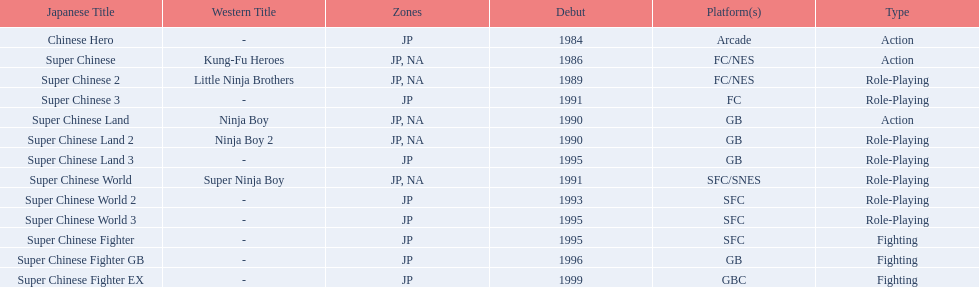Could you parse the entire table as a dict? {'header': ['Japanese Title', 'Western Title', 'Zones', 'Debut', 'Platform(s)', 'Type'], 'rows': [['Chinese Hero', '-', 'JP', '1984', 'Arcade', 'Action'], ['Super Chinese', 'Kung-Fu Heroes', 'JP, NA', '1986', 'FC/NES', 'Action'], ['Super Chinese 2', 'Little Ninja Brothers', 'JP, NA', '1989', 'FC/NES', 'Role-Playing'], ['Super Chinese 3', '-', 'JP', '1991', 'FC', 'Role-Playing'], ['Super Chinese Land', 'Ninja Boy', 'JP, NA', '1990', 'GB', 'Action'], ['Super Chinese Land 2', 'Ninja Boy 2', 'JP, NA', '1990', 'GB', 'Role-Playing'], ['Super Chinese Land 3', '-', 'JP', '1995', 'GB', 'Role-Playing'], ['Super Chinese World', 'Super Ninja Boy', 'JP, NA', '1991', 'SFC/SNES', 'Role-Playing'], ['Super Chinese World 2', '-', 'JP', '1993', 'SFC', 'Role-Playing'], ['Super Chinese World 3', '-', 'JP', '1995', 'SFC', 'Role-Playing'], ['Super Chinese Fighter', '-', 'JP', '1995', 'SFC', 'Fighting'], ['Super Chinese Fighter GB', '-', 'JP', '1996', 'GB', 'Fighting'], ['Super Chinese Fighter EX', '-', 'JP', '1999', 'GBC', 'Fighting']]} The first year a game was released in north america 1986. 